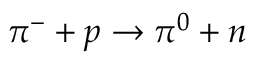<formula> <loc_0><loc_0><loc_500><loc_500>\pi ^ { - } + p \rightarrow \pi ^ { 0 } + n</formula> 